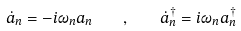Convert formula to latex. <formula><loc_0><loc_0><loc_500><loc_500>\dot { a } _ { n } = - i \omega _ { n } a _ { n } \quad , \quad \dot { a } _ { n } ^ { \dagger } = i \omega _ { n } a _ { n } ^ { \dagger }</formula> 